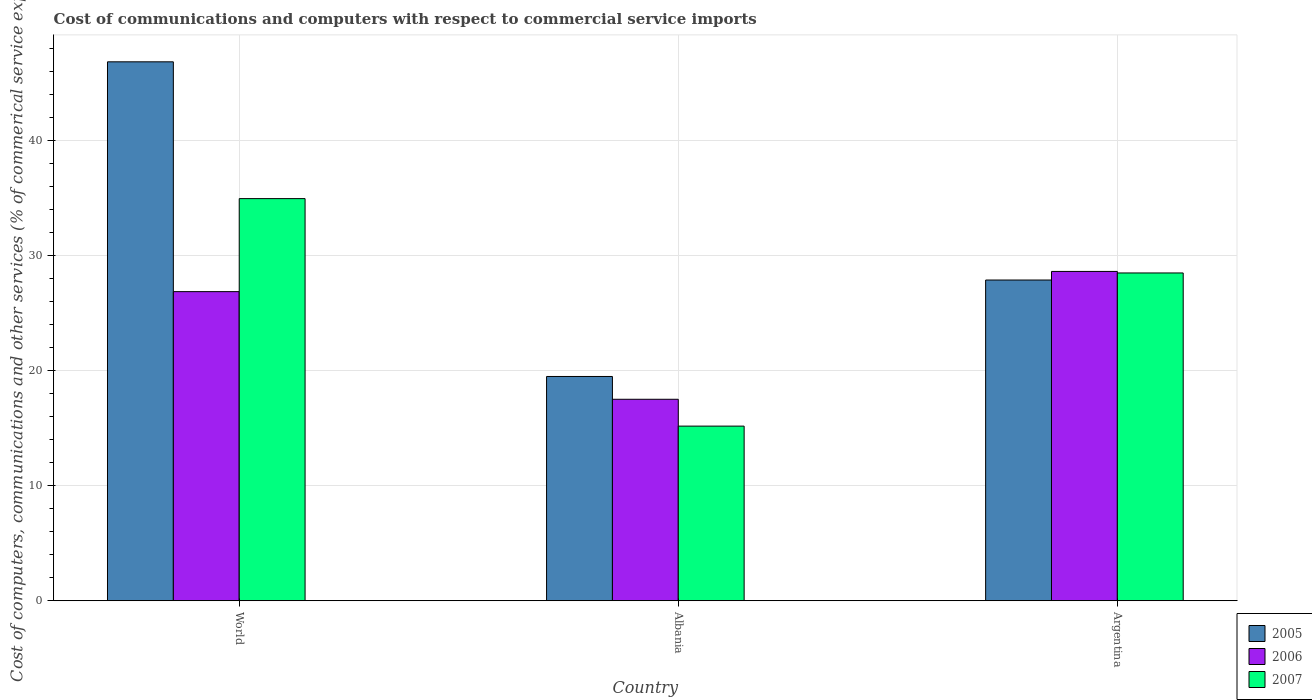How many groups of bars are there?
Ensure brevity in your answer.  3. Are the number of bars per tick equal to the number of legend labels?
Make the answer very short. Yes. How many bars are there on the 2nd tick from the right?
Ensure brevity in your answer.  3. What is the label of the 1st group of bars from the left?
Provide a short and direct response. World. In how many cases, is the number of bars for a given country not equal to the number of legend labels?
Keep it short and to the point. 0. What is the cost of communications and computers in 2006 in World?
Offer a terse response. 26.88. Across all countries, what is the maximum cost of communications and computers in 2007?
Ensure brevity in your answer.  34.97. Across all countries, what is the minimum cost of communications and computers in 2007?
Offer a terse response. 15.19. In which country was the cost of communications and computers in 2006 minimum?
Provide a short and direct response. Albania. What is the total cost of communications and computers in 2005 in the graph?
Ensure brevity in your answer.  94.26. What is the difference between the cost of communications and computers in 2006 in Albania and that in World?
Make the answer very short. -9.36. What is the difference between the cost of communications and computers in 2006 in World and the cost of communications and computers in 2007 in Albania?
Your answer should be very brief. 11.69. What is the average cost of communications and computers in 2006 per country?
Your response must be concise. 24.35. What is the difference between the cost of communications and computers of/in 2006 and cost of communications and computers of/in 2005 in World?
Offer a very short reply. -19.98. In how many countries, is the cost of communications and computers in 2006 greater than 40 %?
Provide a succinct answer. 0. What is the ratio of the cost of communications and computers in 2007 in Argentina to that in World?
Your answer should be compact. 0.82. Is the cost of communications and computers in 2006 in Albania less than that in World?
Offer a terse response. Yes. Is the difference between the cost of communications and computers in 2006 in Argentina and World greater than the difference between the cost of communications and computers in 2005 in Argentina and World?
Make the answer very short. Yes. What is the difference between the highest and the second highest cost of communications and computers in 2005?
Make the answer very short. -8.39. What is the difference between the highest and the lowest cost of communications and computers in 2005?
Provide a short and direct response. 27.36. In how many countries, is the cost of communications and computers in 2007 greater than the average cost of communications and computers in 2007 taken over all countries?
Ensure brevity in your answer.  2. What does the 3rd bar from the left in Albania represents?
Give a very brief answer. 2007. What does the 1st bar from the right in Argentina represents?
Make the answer very short. 2007. How many bars are there?
Ensure brevity in your answer.  9. Are all the bars in the graph horizontal?
Keep it short and to the point. No. What is the difference between two consecutive major ticks on the Y-axis?
Make the answer very short. 10. Are the values on the major ticks of Y-axis written in scientific E-notation?
Make the answer very short. No. Does the graph contain grids?
Provide a short and direct response. Yes. Where does the legend appear in the graph?
Offer a very short reply. Bottom right. How many legend labels are there?
Make the answer very short. 3. What is the title of the graph?
Ensure brevity in your answer.  Cost of communications and computers with respect to commercial service imports. What is the label or title of the Y-axis?
Offer a terse response. Cost of computers, communications and other services (% of commerical service exports). What is the Cost of computers, communications and other services (% of commerical service exports) in 2005 in World?
Ensure brevity in your answer.  46.86. What is the Cost of computers, communications and other services (% of commerical service exports) in 2006 in World?
Give a very brief answer. 26.88. What is the Cost of computers, communications and other services (% of commerical service exports) in 2007 in World?
Your answer should be compact. 34.97. What is the Cost of computers, communications and other services (% of commerical service exports) in 2005 in Albania?
Offer a terse response. 19.5. What is the Cost of computers, communications and other services (% of commerical service exports) in 2006 in Albania?
Your answer should be compact. 17.52. What is the Cost of computers, communications and other services (% of commerical service exports) in 2007 in Albania?
Ensure brevity in your answer.  15.19. What is the Cost of computers, communications and other services (% of commerical service exports) in 2005 in Argentina?
Offer a terse response. 27.89. What is the Cost of computers, communications and other services (% of commerical service exports) in 2006 in Argentina?
Keep it short and to the point. 28.64. What is the Cost of computers, communications and other services (% of commerical service exports) of 2007 in Argentina?
Offer a very short reply. 28.5. Across all countries, what is the maximum Cost of computers, communications and other services (% of commerical service exports) in 2005?
Ensure brevity in your answer.  46.86. Across all countries, what is the maximum Cost of computers, communications and other services (% of commerical service exports) in 2006?
Your answer should be compact. 28.64. Across all countries, what is the maximum Cost of computers, communications and other services (% of commerical service exports) of 2007?
Offer a terse response. 34.97. Across all countries, what is the minimum Cost of computers, communications and other services (% of commerical service exports) of 2005?
Provide a short and direct response. 19.5. Across all countries, what is the minimum Cost of computers, communications and other services (% of commerical service exports) in 2006?
Offer a very short reply. 17.52. Across all countries, what is the minimum Cost of computers, communications and other services (% of commerical service exports) in 2007?
Make the answer very short. 15.19. What is the total Cost of computers, communications and other services (% of commerical service exports) of 2005 in the graph?
Offer a terse response. 94.26. What is the total Cost of computers, communications and other services (% of commerical service exports) in 2006 in the graph?
Offer a very short reply. 73.04. What is the total Cost of computers, communications and other services (% of commerical service exports) of 2007 in the graph?
Keep it short and to the point. 78.66. What is the difference between the Cost of computers, communications and other services (% of commerical service exports) of 2005 in World and that in Albania?
Offer a terse response. 27.36. What is the difference between the Cost of computers, communications and other services (% of commerical service exports) in 2006 in World and that in Albania?
Offer a terse response. 9.36. What is the difference between the Cost of computers, communications and other services (% of commerical service exports) in 2007 in World and that in Albania?
Offer a terse response. 19.78. What is the difference between the Cost of computers, communications and other services (% of commerical service exports) in 2005 in World and that in Argentina?
Give a very brief answer. 18.97. What is the difference between the Cost of computers, communications and other services (% of commerical service exports) in 2006 in World and that in Argentina?
Ensure brevity in your answer.  -1.76. What is the difference between the Cost of computers, communications and other services (% of commerical service exports) of 2007 in World and that in Argentina?
Offer a terse response. 6.46. What is the difference between the Cost of computers, communications and other services (% of commerical service exports) of 2005 in Albania and that in Argentina?
Provide a succinct answer. -8.39. What is the difference between the Cost of computers, communications and other services (% of commerical service exports) of 2006 in Albania and that in Argentina?
Provide a succinct answer. -11.12. What is the difference between the Cost of computers, communications and other services (% of commerical service exports) of 2007 in Albania and that in Argentina?
Ensure brevity in your answer.  -13.32. What is the difference between the Cost of computers, communications and other services (% of commerical service exports) of 2005 in World and the Cost of computers, communications and other services (% of commerical service exports) of 2006 in Albania?
Your answer should be very brief. 29.34. What is the difference between the Cost of computers, communications and other services (% of commerical service exports) of 2005 in World and the Cost of computers, communications and other services (% of commerical service exports) of 2007 in Albania?
Offer a very short reply. 31.68. What is the difference between the Cost of computers, communications and other services (% of commerical service exports) in 2006 in World and the Cost of computers, communications and other services (% of commerical service exports) in 2007 in Albania?
Your answer should be compact. 11.69. What is the difference between the Cost of computers, communications and other services (% of commerical service exports) in 2005 in World and the Cost of computers, communications and other services (% of commerical service exports) in 2006 in Argentina?
Give a very brief answer. 18.23. What is the difference between the Cost of computers, communications and other services (% of commerical service exports) of 2005 in World and the Cost of computers, communications and other services (% of commerical service exports) of 2007 in Argentina?
Offer a very short reply. 18.36. What is the difference between the Cost of computers, communications and other services (% of commerical service exports) in 2006 in World and the Cost of computers, communications and other services (% of commerical service exports) in 2007 in Argentina?
Give a very brief answer. -1.62. What is the difference between the Cost of computers, communications and other services (% of commerical service exports) of 2005 in Albania and the Cost of computers, communications and other services (% of commerical service exports) of 2006 in Argentina?
Your response must be concise. -9.13. What is the difference between the Cost of computers, communications and other services (% of commerical service exports) in 2005 in Albania and the Cost of computers, communications and other services (% of commerical service exports) in 2007 in Argentina?
Your answer should be compact. -9. What is the difference between the Cost of computers, communications and other services (% of commerical service exports) in 2006 in Albania and the Cost of computers, communications and other services (% of commerical service exports) in 2007 in Argentina?
Provide a short and direct response. -10.98. What is the average Cost of computers, communications and other services (% of commerical service exports) of 2005 per country?
Your answer should be compact. 31.42. What is the average Cost of computers, communications and other services (% of commerical service exports) of 2006 per country?
Your answer should be compact. 24.35. What is the average Cost of computers, communications and other services (% of commerical service exports) in 2007 per country?
Make the answer very short. 26.22. What is the difference between the Cost of computers, communications and other services (% of commerical service exports) in 2005 and Cost of computers, communications and other services (% of commerical service exports) in 2006 in World?
Ensure brevity in your answer.  19.98. What is the difference between the Cost of computers, communications and other services (% of commerical service exports) in 2005 and Cost of computers, communications and other services (% of commerical service exports) in 2007 in World?
Provide a short and direct response. 11.89. What is the difference between the Cost of computers, communications and other services (% of commerical service exports) of 2006 and Cost of computers, communications and other services (% of commerical service exports) of 2007 in World?
Offer a terse response. -8.09. What is the difference between the Cost of computers, communications and other services (% of commerical service exports) of 2005 and Cost of computers, communications and other services (% of commerical service exports) of 2006 in Albania?
Give a very brief answer. 1.98. What is the difference between the Cost of computers, communications and other services (% of commerical service exports) in 2005 and Cost of computers, communications and other services (% of commerical service exports) in 2007 in Albania?
Your response must be concise. 4.32. What is the difference between the Cost of computers, communications and other services (% of commerical service exports) of 2006 and Cost of computers, communications and other services (% of commerical service exports) of 2007 in Albania?
Give a very brief answer. 2.33. What is the difference between the Cost of computers, communications and other services (% of commerical service exports) in 2005 and Cost of computers, communications and other services (% of commerical service exports) in 2006 in Argentina?
Make the answer very short. -0.75. What is the difference between the Cost of computers, communications and other services (% of commerical service exports) of 2005 and Cost of computers, communications and other services (% of commerical service exports) of 2007 in Argentina?
Your answer should be very brief. -0.61. What is the difference between the Cost of computers, communications and other services (% of commerical service exports) of 2006 and Cost of computers, communications and other services (% of commerical service exports) of 2007 in Argentina?
Your answer should be compact. 0.13. What is the ratio of the Cost of computers, communications and other services (% of commerical service exports) in 2005 in World to that in Albania?
Your response must be concise. 2.4. What is the ratio of the Cost of computers, communications and other services (% of commerical service exports) of 2006 in World to that in Albania?
Your response must be concise. 1.53. What is the ratio of the Cost of computers, communications and other services (% of commerical service exports) in 2007 in World to that in Albania?
Give a very brief answer. 2.3. What is the ratio of the Cost of computers, communications and other services (% of commerical service exports) of 2005 in World to that in Argentina?
Provide a short and direct response. 1.68. What is the ratio of the Cost of computers, communications and other services (% of commerical service exports) in 2006 in World to that in Argentina?
Provide a succinct answer. 0.94. What is the ratio of the Cost of computers, communications and other services (% of commerical service exports) of 2007 in World to that in Argentina?
Offer a very short reply. 1.23. What is the ratio of the Cost of computers, communications and other services (% of commerical service exports) in 2005 in Albania to that in Argentina?
Make the answer very short. 0.7. What is the ratio of the Cost of computers, communications and other services (% of commerical service exports) of 2006 in Albania to that in Argentina?
Provide a succinct answer. 0.61. What is the ratio of the Cost of computers, communications and other services (% of commerical service exports) of 2007 in Albania to that in Argentina?
Keep it short and to the point. 0.53. What is the difference between the highest and the second highest Cost of computers, communications and other services (% of commerical service exports) of 2005?
Offer a terse response. 18.97. What is the difference between the highest and the second highest Cost of computers, communications and other services (% of commerical service exports) in 2006?
Provide a short and direct response. 1.76. What is the difference between the highest and the second highest Cost of computers, communications and other services (% of commerical service exports) in 2007?
Ensure brevity in your answer.  6.46. What is the difference between the highest and the lowest Cost of computers, communications and other services (% of commerical service exports) in 2005?
Make the answer very short. 27.36. What is the difference between the highest and the lowest Cost of computers, communications and other services (% of commerical service exports) in 2006?
Your answer should be very brief. 11.12. What is the difference between the highest and the lowest Cost of computers, communications and other services (% of commerical service exports) in 2007?
Give a very brief answer. 19.78. 